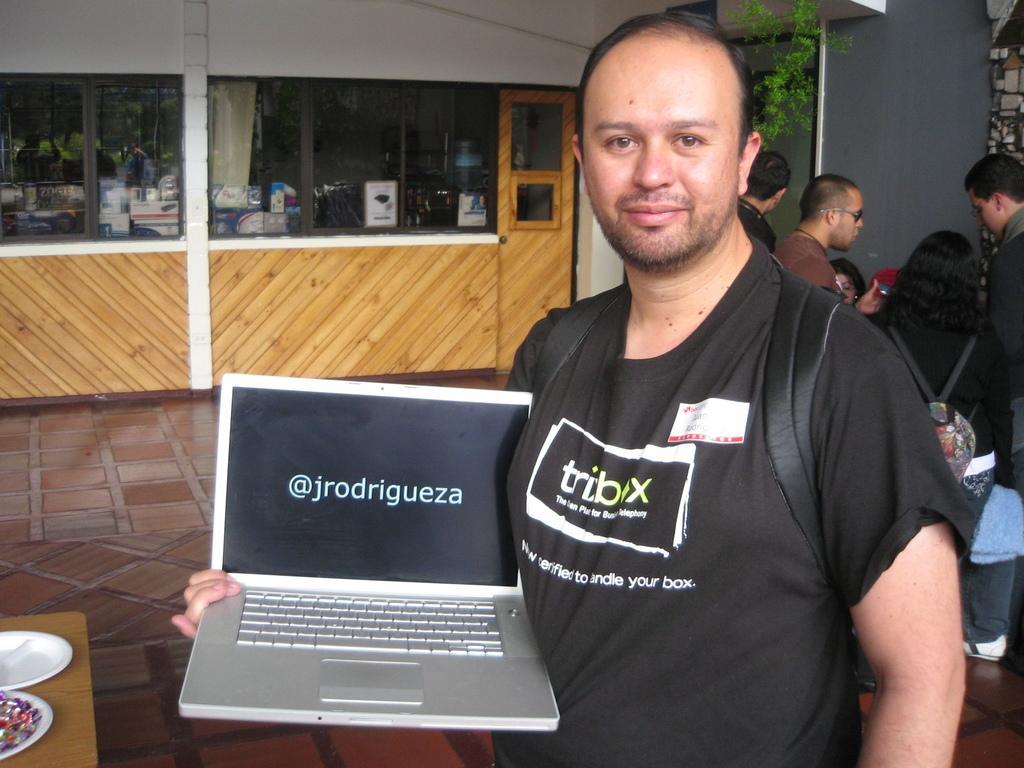Describe this image in one or two sentences. Here in this picture, in the front we can see a man standing over a place and she is carrying a bag and holding a laptop in his hand and smiling and behind him we can see other number of people standing over a place and on the left side we can see a table, on which we can see plates present and behind him in the far we can see a store, in which we can see number of things present and we can also see a plant present. 